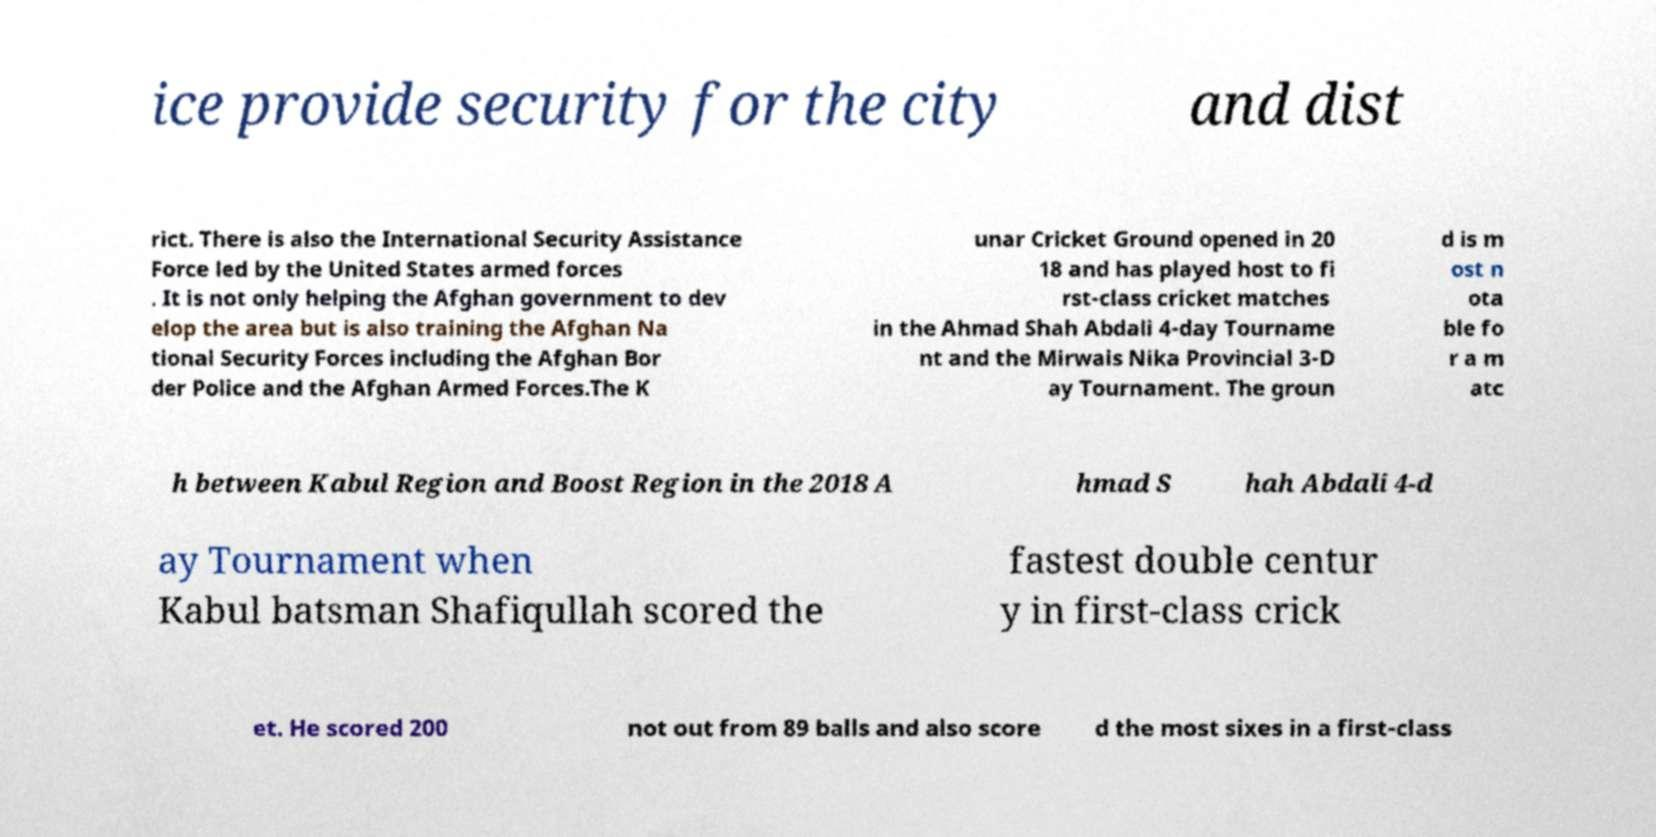Could you assist in decoding the text presented in this image and type it out clearly? ice provide security for the city and dist rict. There is also the International Security Assistance Force led by the United States armed forces . It is not only helping the Afghan government to dev elop the area but is also training the Afghan Na tional Security Forces including the Afghan Bor der Police and the Afghan Armed Forces.The K unar Cricket Ground opened in 20 18 and has played host to fi rst-class cricket matches in the Ahmad Shah Abdali 4-day Tourname nt and the Mirwais Nika Provincial 3-D ay Tournament. The groun d is m ost n ota ble fo r a m atc h between Kabul Region and Boost Region in the 2018 A hmad S hah Abdali 4-d ay Tournament when Kabul batsman Shafiqullah scored the fastest double centur y in first-class crick et. He scored 200 not out from 89 balls and also score d the most sixes in a first-class 